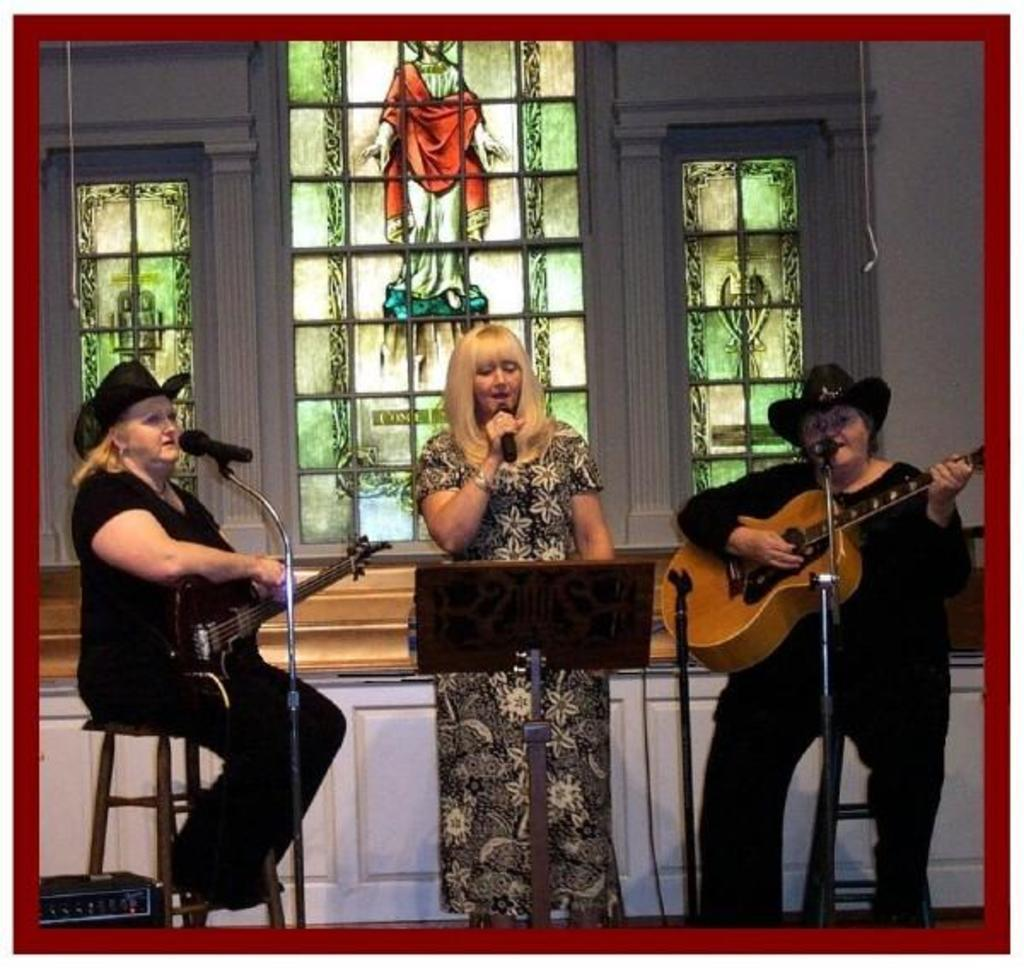How many women are present in the image? There are three women in the image. What is one woman doing in the image? One woman is singing a song. What is another woman holding in the image? One woman is holding a guitar. What is the third woman holding in the image? The third woman is holding a microphone. How many legs does the guitar have in the image? The guitar in the image does not have legs; it is a musical instrument held by one of the women. --- Transcript: In this picture we can see a man holding a camera and a woman holding a book. They are standing in front of a building. Facts: 1. There is a man in the image. 2. The man is holding a camera. 3. There is a woman in the image. 4. The woman is holding a book. 5. They are standing in front of a building. Absurd Topics: dance, ocean, wings Conversation: What is the man holding in the image? The man is holding a camera in the image. What is the woman holding in the image? The woman is holding a book in the image. Where are the man and woman standing in the image? They are standing in front of a building in the image. Reasoning: Let's think step by step in order to produce the conversation. We start by identifying the main subjects in the image, which are the man and the woman. Then, we describe the objects they are holding, ensuring that each question can be answered definitively with the information given. We avoid yes/no questions and ensure that the language is simple and clear. Absurd Question/Answer: Can you see any wings on the man in the image? No, there are no wings visible on the man in the image. --- Transcript: In this image we can see a person sitting on a chair and reading a book. There is a table in front of the person with a cup of coffee on it. Facts: 1. There is a person in the image. 2. The person is sitting on a chair. 3. The person is reading a book. 4. There is a table in front of the person. 5. There is a cup of coffee on the table. Absurd Topics: dance, ocean, wings Conversation: What is the person doing in the image? The person is sitting on a chair and reading a book in the image. What is on the table in front of the person? There is a cup of coffee on the table in the image. Reasoning: Let's think step by step in order to produce the conversation. We start by identifying the main subject in the image, which is the person. Then, we describe the actions and objects associated with the person, ensuring that each question can be answered definitively with the information given. We avoid yes/no questions and ensure that the 